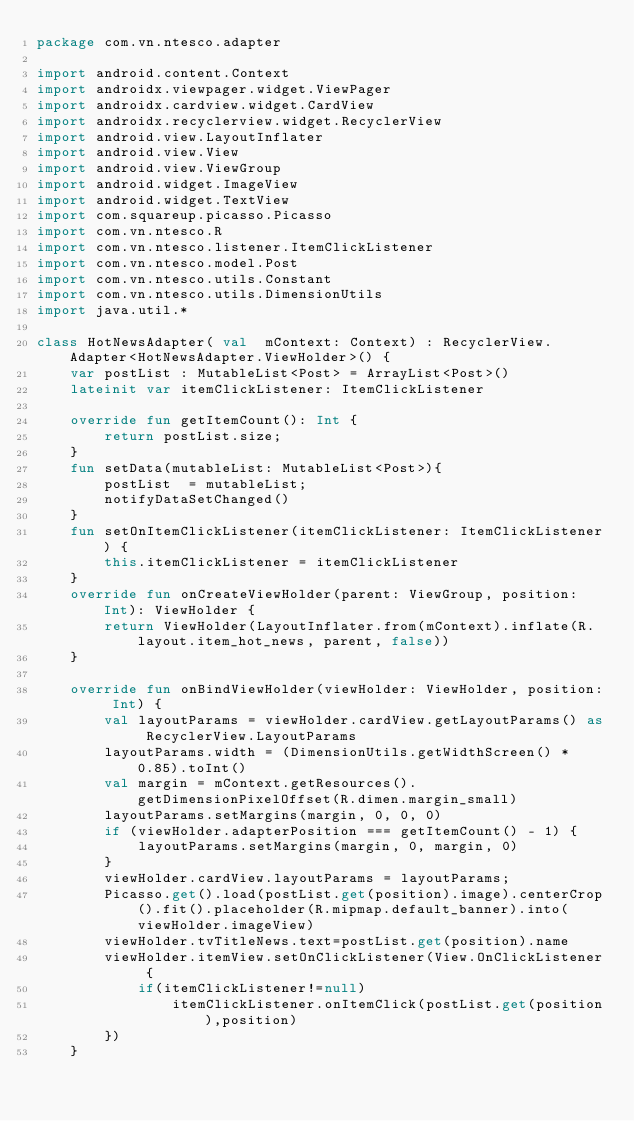<code> <loc_0><loc_0><loc_500><loc_500><_Kotlin_>package com.vn.ntesco.adapter

import android.content.Context
import androidx.viewpager.widget.ViewPager
import androidx.cardview.widget.CardView
import androidx.recyclerview.widget.RecyclerView
import android.view.LayoutInflater
import android.view.View
import android.view.ViewGroup
import android.widget.ImageView
import android.widget.TextView
import com.squareup.picasso.Picasso
import com.vn.ntesco.R
import com.vn.ntesco.listener.ItemClickListener
import com.vn.ntesco.model.Post
import com.vn.ntesco.utils.Constant
import com.vn.ntesco.utils.DimensionUtils
import java.util.*

class HotNewsAdapter( val  mContext: Context) : RecyclerView.Adapter<HotNewsAdapter.ViewHolder>() {
    var postList : MutableList<Post> = ArrayList<Post>()
    lateinit var itemClickListener: ItemClickListener

    override fun getItemCount(): Int {
        return postList.size;
    }
    fun setData(mutableList: MutableList<Post>){
        postList  = mutableList;
        notifyDataSetChanged()
    }
    fun setOnItemClickListener(itemClickListener: ItemClickListener) {
        this.itemClickListener = itemClickListener
    }
    override fun onCreateViewHolder(parent: ViewGroup, position: Int): ViewHolder {
        return ViewHolder(LayoutInflater.from(mContext).inflate(R.layout.item_hot_news, parent, false))
    }

    override fun onBindViewHolder(viewHolder: ViewHolder, position: Int) {
        val layoutParams = viewHolder.cardView.getLayoutParams() as RecyclerView.LayoutParams
        layoutParams.width = (DimensionUtils.getWidthScreen() * 0.85).toInt()
        val margin = mContext.getResources().getDimensionPixelOffset(R.dimen.margin_small)
        layoutParams.setMargins(margin, 0, 0, 0)
        if (viewHolder.adapterPosition === getItemCount() - 1) {
            layoutParams.setMargins(margin, 0, margin, 0)
        }
        viewHolder.cardView.layoutParams = layoutParams;
        Picasso.get().load(postList.get(position).image).centerCrop().fit().placeholder(R.mipmap.default_banner).into(viewHolder.imageView)
        viewHolder.tvTitleNews.text=postList.get(position).name
        viewHolder.itemView.setOnClickListener(View.OnClickListener {
            if(itemClickListener!=null)
                itemClickListener.onItemClick(postList.get(position),position)
        })
    }

</code> 